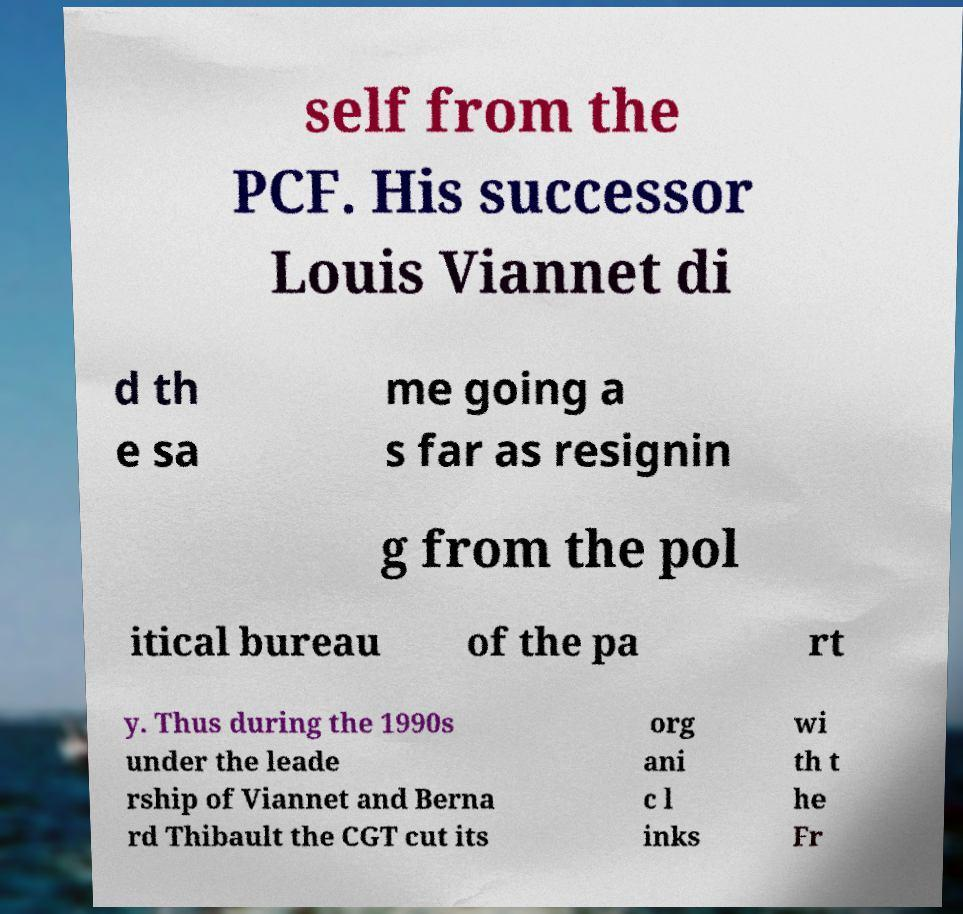Can you read and provide the text displayed in the image?This photo seems to have some interesting text. Can you extract and type it out for me? self from the PCF. His successor Louis Viannet di d th e sa me going a s far as resignin g from the pol itical bureau of the pa rt y. Thus during the 1990s under the leade rship of Viannet and Berna rd Thibault the CGT cut its org ani c l inks wi th t he Fr 